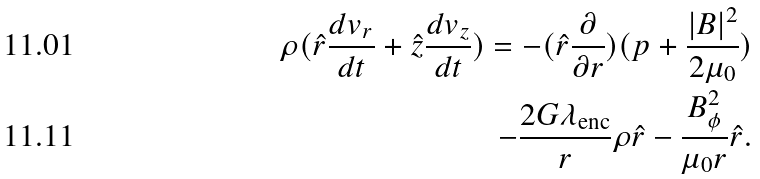Convert formula to latex. <formula><loc_0><loc_0><loc_500><loc_500>\rho ( \hat { r } \frac { d v _ { r } } { d t } + \hat { z } \frac { d v _ { z } } { d t } ) = - ( \hat { r } \frac { \partial } { \partial r } ) ( p + \frac { | B | ^ { 2 } } { 2 \mu _ { 0 } } ) \\ - \frac { 2 G \lambda _ { \text {enc} } } { r } \rho \hat { r } - \frac { B _ { \phi } ^ { 2 } } { \mu _ { 0 } r } \hat { r } .</formula> 